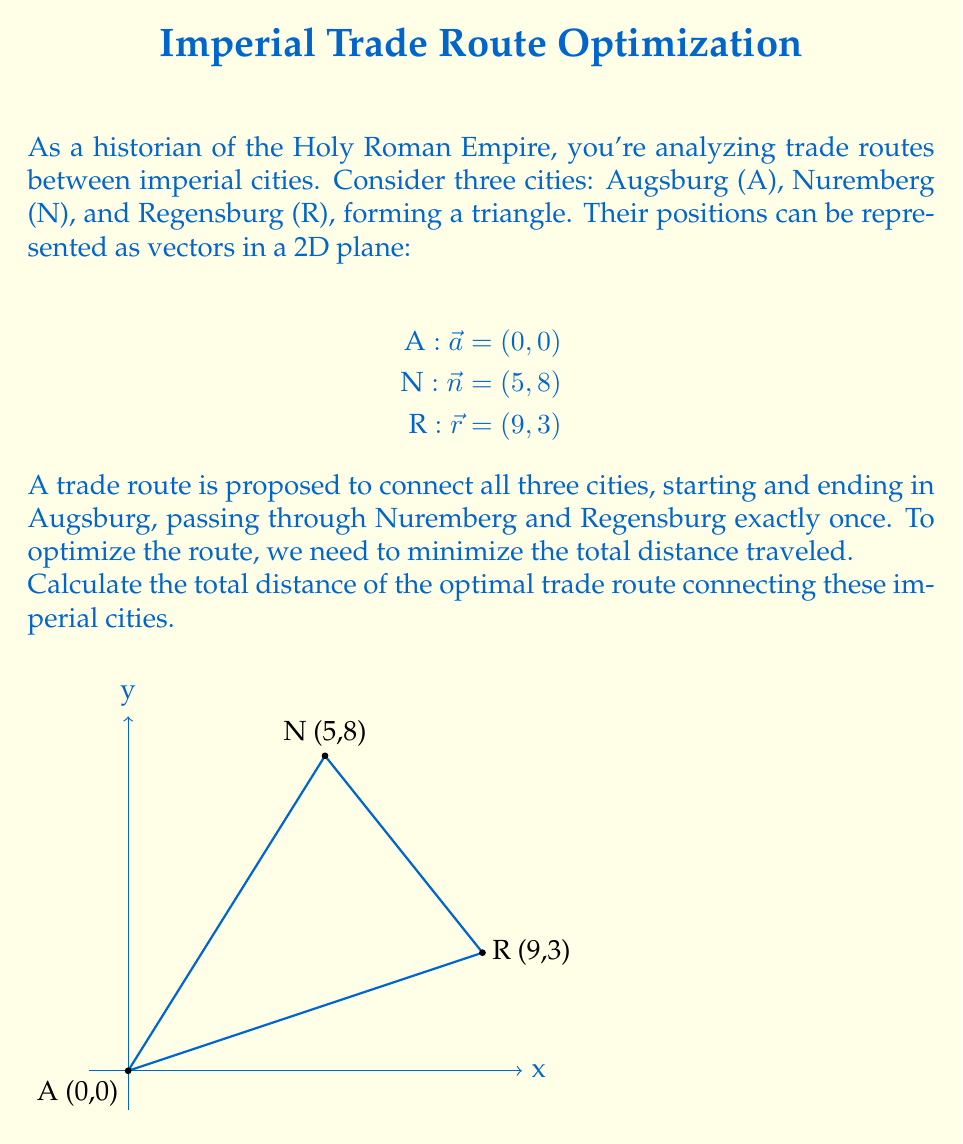What is the answer to this math problem? To solve this problem, we'll follow these steps:

1) First, we need to calculate the distances between each pair of cities. We can do this using the distance formula derived from the Pythagorean theorem:

   Distance = $\sqrt{(x_2-x_1)^2 + (y_2-y_1)^2}$

2) Calculate distance from A to N:
   $d_{AN} = \sqrt{(5-0)^2 + (8-0)^2} = \sqrt{25 + 64} = \sqrt{89}$

3) Calculate distance from N to R:
   $d_{NR} = \sqrt{(9-5)^2 + (3-8)^2} = \sqrt{16 + 25} = \sqrt{41}$

4) Calculate distance from R to A:
   $d_{RA} = \sqrt{(0-9)^2 + (0-3)^2} = \sqrt{81 + 9} = \sqrt{90}$

5) The total distance of the route A → N → R → A is:
   $d_{total} = d_{AN} + d_{NR} + d_{RA} = \sqrt{89} + \sqrt{41} + \sqrt{90}$

6) Simplify:
   $d_{total} = \sqrt{89} + \sqrt{41} + 3\sqrt{10}$

This is the shortest possible route connecting all three cities, starting and ending in Augsburg. Any other permutation of the cities would result in a longer total distance.
Answer: $\sqrt{89} + \sqrt{41} + 3\sqrt{10}$ 